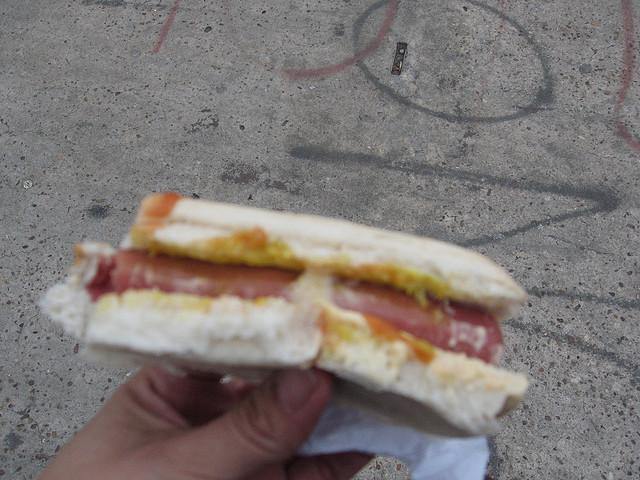Is it an outdoor scene?
Concise answer only. Yes. What is the food?
Quick response, please. Hot dog. Is the hot dog too big for the bun?
Concise answer only. No. Is the hot dog in a bun?
Give a very brief answer. Yes. 